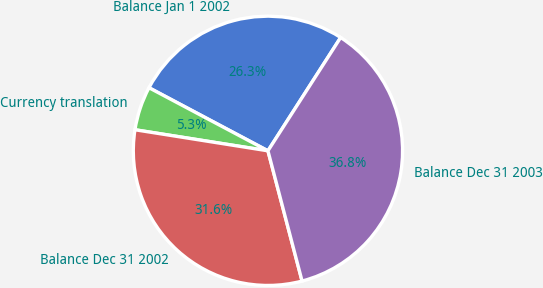Convert chart to OTSL. <chart><loc_0><loc_0><loc_500><loc_500><pie_chart><fcel>Balance Jan 1 2002<fcel>Currency translation<fcel>Balance Dec 31 2002<fcel>Balance Dec 31 2003<nl><fcel>26.32%<fcel>5.26%<fcel>31.58%<fcel>36.84%<nl></chart> 